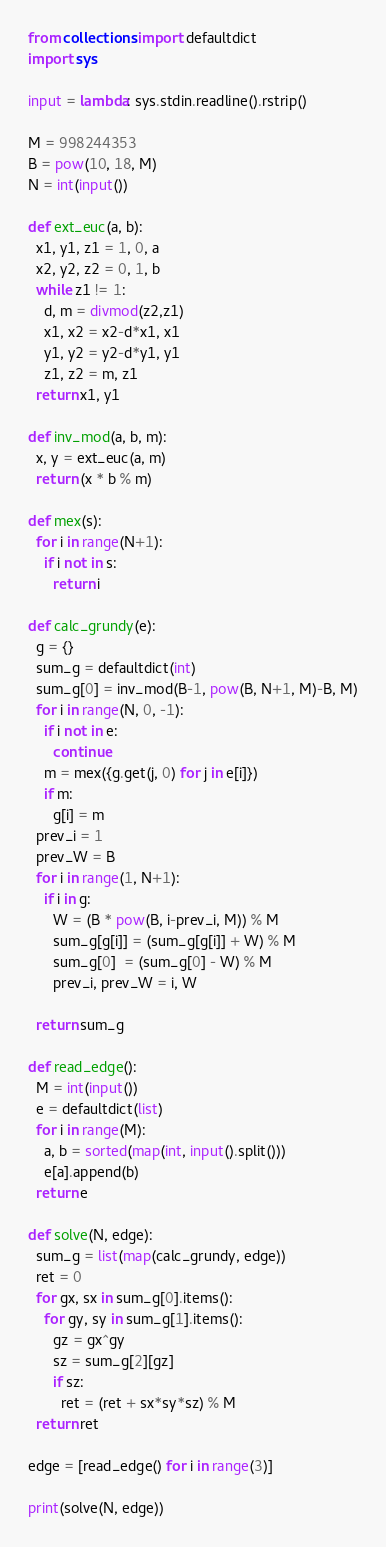Convert code to text. <code><loc_0><loc_0><loc_500><loc_500><_Python_>from collections import defaultdict
import sys

input = lambda: sys.stdin.readline().rstrip()

M = 998244353
B = pow(10, 18, M)
N = int(input())

def ext_euc(a, b):
  x1, y1, z1 = 1, 0, a
  x2, y2, z2 = 0, 1, b
  while z1 != 1:
    d, m = divmod(z2,z1)
    x1, x2 = x2-d*x1, x1
    y1, y2 = y2-d*y1, y1
    z1, z2 = m, z1
  return x1, y1

def inv_mod(a, b, m):
  x, y = ext_euc(a, m)
  return (x * b % m)

def mex(s):
  for i in range(N+1):
    if i not in s:
      return i

def calc_grundy(e):
  g = {}
  sum_g = defaultdict(int)
  sum_g[0] = inv_mod(B-1, pow(B, N+1, M)-B, M)
  for i in range(N, 0, -1):
    if i not in e:
      continue
    m = mex({g.get(j, 0) for j in e[i]})
    if m:
      g[i] = m
  prev_i = 1
  prev_W = B
  for i in range(1, N+1):
    if i in g:
      W = (B * pow(B, i-prev_i, M)) % M
      sum_g[g[i]] = (sum_g[g[i]] + W) % M
      sum_g[0]  = (sum_g[0] - W) % M
      prev_i, prev_W = i, W
  
  return sum_g

def read_edge():
  M = int(input())
  e = defaultdict(list)
  for i in range(M):
    a, b = sorted(map(int, input().split()))
    e[a].append(b)
  return e

def solve(N, edge):
  sum_g = list(map(calc_grundy, edge))
  ret = 0
  for gx, sx in sum_g[0].items():
    for gy, sy in sum_g[1].items():
      gz = gx^gy
      sz = sum_g[2][gz]
      if sz:
        ret = (ret + sx*sy*sz) % M
  return ret

edge = [read_edge() for i in range(3)]

print(solve(N, edge))</code> 